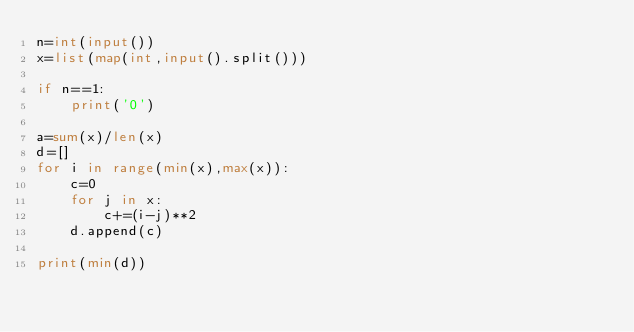<code> <loc_0><loc_0><loc_500><loc_500><_Python_>n=int(input())
x=list(map(int,input().split()))

if n==1:
    print('0')

a=sum(x)/len(x)
d=[]
for i in range(min(x),max(x)):
    c=0
    for j in x:
        c+=(i-j)**2
    d.append(c)

print(min(d))</code> 